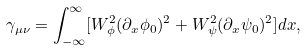<formula> <loc_0><loc_0><loc_500><loc_500>\gamma _ { \mu \nu } = \int _ { - \infty } ^ { \infty } [ W _ { \phi } ^ { 2 } ( \partial _ { x } \phi _ { 0 } ) ^ { 2 } + W _ { \psi } ^ { 2 } ( \partial _ { x } \psi _ { 0 } ) ^ { 2 } ] d x ,</formula> 